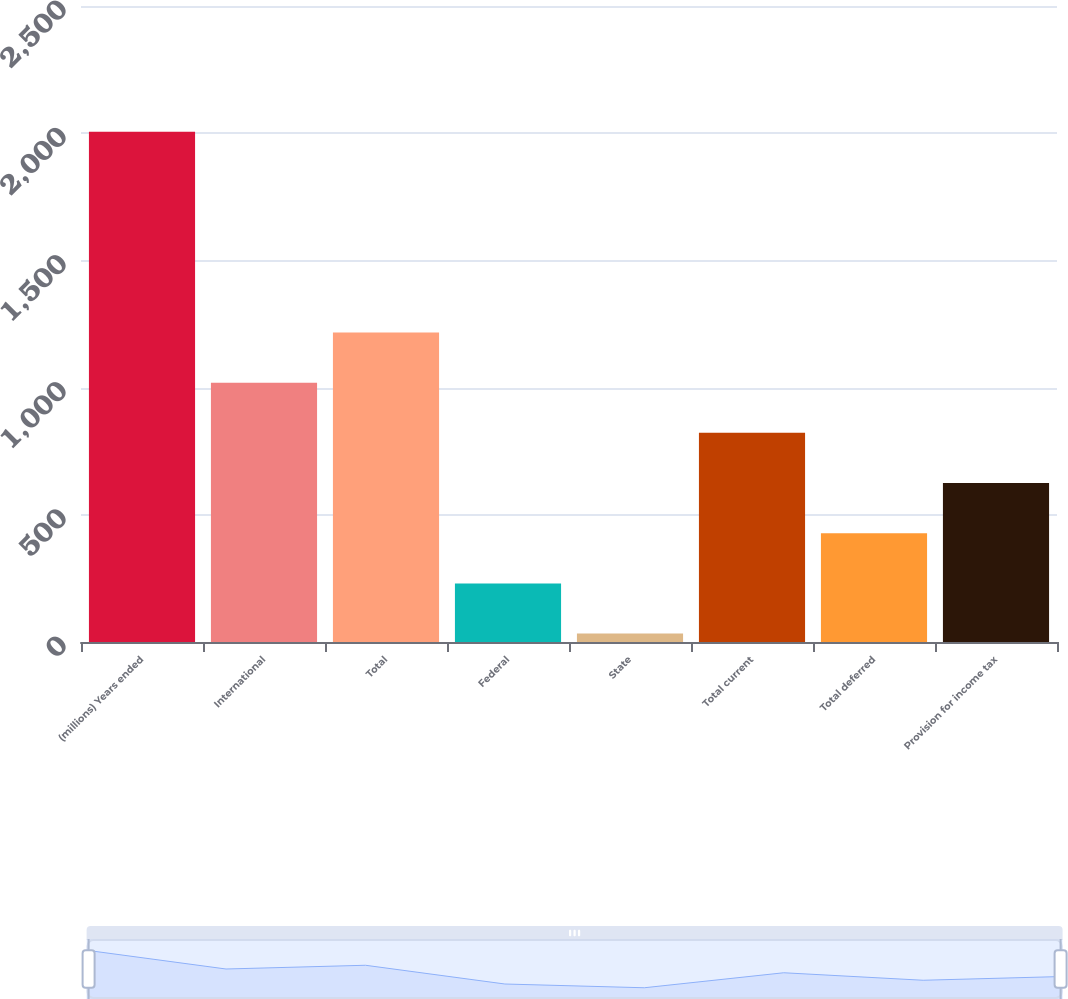<chart> <loc_0><loc_0><loc_500><loc_500><bar_chart><fcel>(millions) Years ended<fcel>International<fcel>Total<fcel>Federal<fcel>State<fcel>Total current<fcel>Total deferred<fcel>Provision for income tax<nl><fcel>2006<fcel>1019.5<fcel>1216.8<fcel>230.3<fcel>33<fcel>822.2<fcel>427.6<fcel>624.9<nl></chart> 